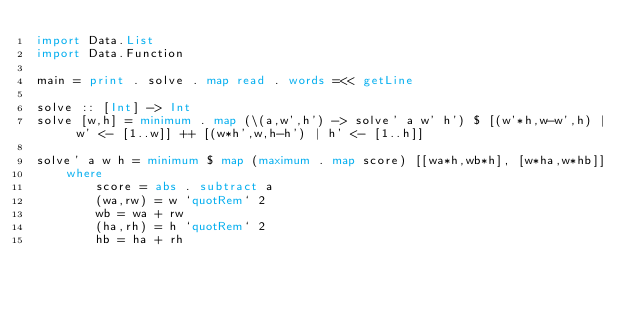Convert code to text. <code><loc_0><loc_0><loc_500><loc_500><_Haskell_>import Data.List
import Data.Function

main = print . solve . map read . words =<< getLine

solve :: [Int] -> Int
solve [w,h] = minimum . map (\(a,w',h') -> solve' a w' h') $ [(w'*h,w-w',h) | w' <- [1..w]] ++ [(w*h',w,h-h') | h' <- [1..h]]

solve' a w h = minimum $ map (maximum . map score) [[wa*h,wb*h], [w*ha,w*hb]]
    where
        score = abs . subtract a
        (wa,rw) = w `quotRem` 2
        wb = wa + rw
        (ha,rh) = h `quotRem` 2
        hb = ha + rh
</code> 